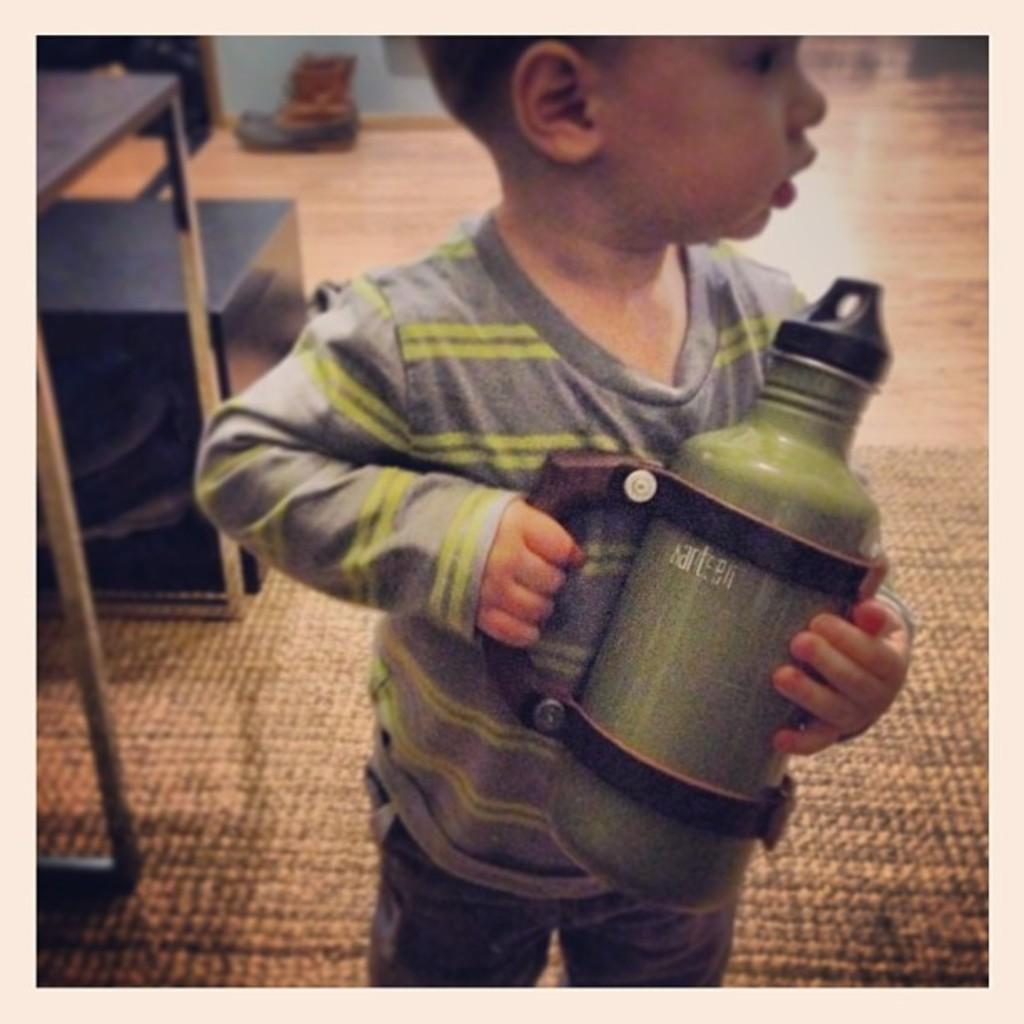Please provide a concise description of this image. In this picture we can see a boy holding a bottle and he is standing on the floor. On the left side of the image, there is a table and an object. At the top of the image, there is a wall. 